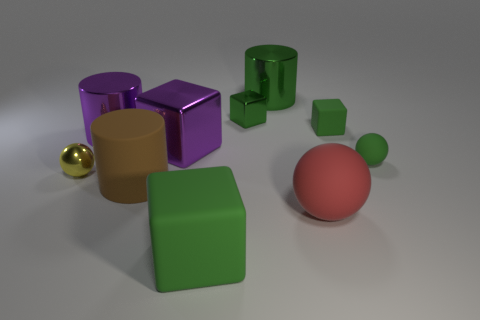Subtract all green blocks. How many were subtracted if there are1green blocks left? 2 Subtract all yellow balls. How many green blocks are left? 3 Subtract all big metal cylinders. How many cylinders are left? 1 Subtract 1 cylinders. How many cylinders are left? 2 Add 8 big purple metal things. How many big purple metal things are left? 10 Add 6 tiny rubber blocks. How many tiny rubber blocks exist? 7 Subtract all purple blocks. How many blocks are left? 3 Subtract 1 brown cylinders. How many objects are left? 9 Subtract all cylinders. How many objects are left? 7 Subtract all brown spheres. Subtract all red cylinders. How many spheres are left? 3 